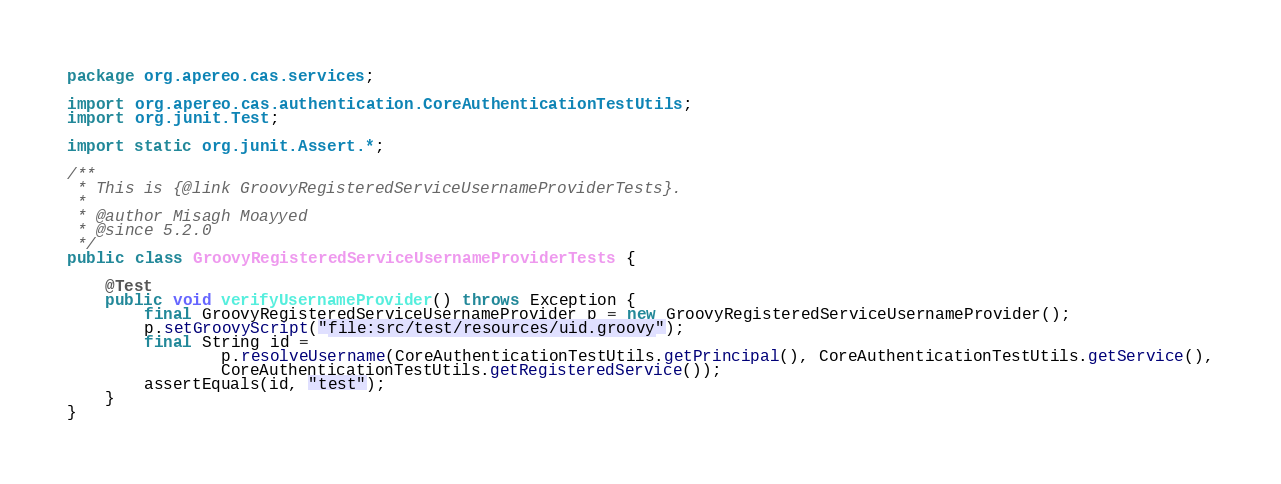Convert code to text. <code><loc_0><loc_0><loc_500><loc_500><_Java_>package org.apereo.cas.services;

import org.apereo.cas.authentication.CoreAuthenticationTestUtils;
import org.junit.Test;

import static org.junit.Assert.*;

/**
 * This is {@link GroovyRegisteredServiceUsernameProviderTests}.
 *
 * @author Misagh Moayyed
 * @since 5.2.0
 */
public class GroovyRegisteredServiceUsernameProviderTests {

    @Test
    public void verifyUsernameProvider() throws Exception {
        final GroovyRegisteredServiceUsernameProvider p = new GroovyRegisteredServiceUsernameProvider();
        p.setGroovyScript("file:src/test/resources/uid.groovy");
        final String id =
                p.resolveUsername(CoreAuthenticationTestUtils.getPrincipal(), CoreAuthenticationTestUtils.getService(),
                CoreAuthenticationTestUtils.getRegisteredService());
        assertEquals(id, "test");
    }
}
</code> 